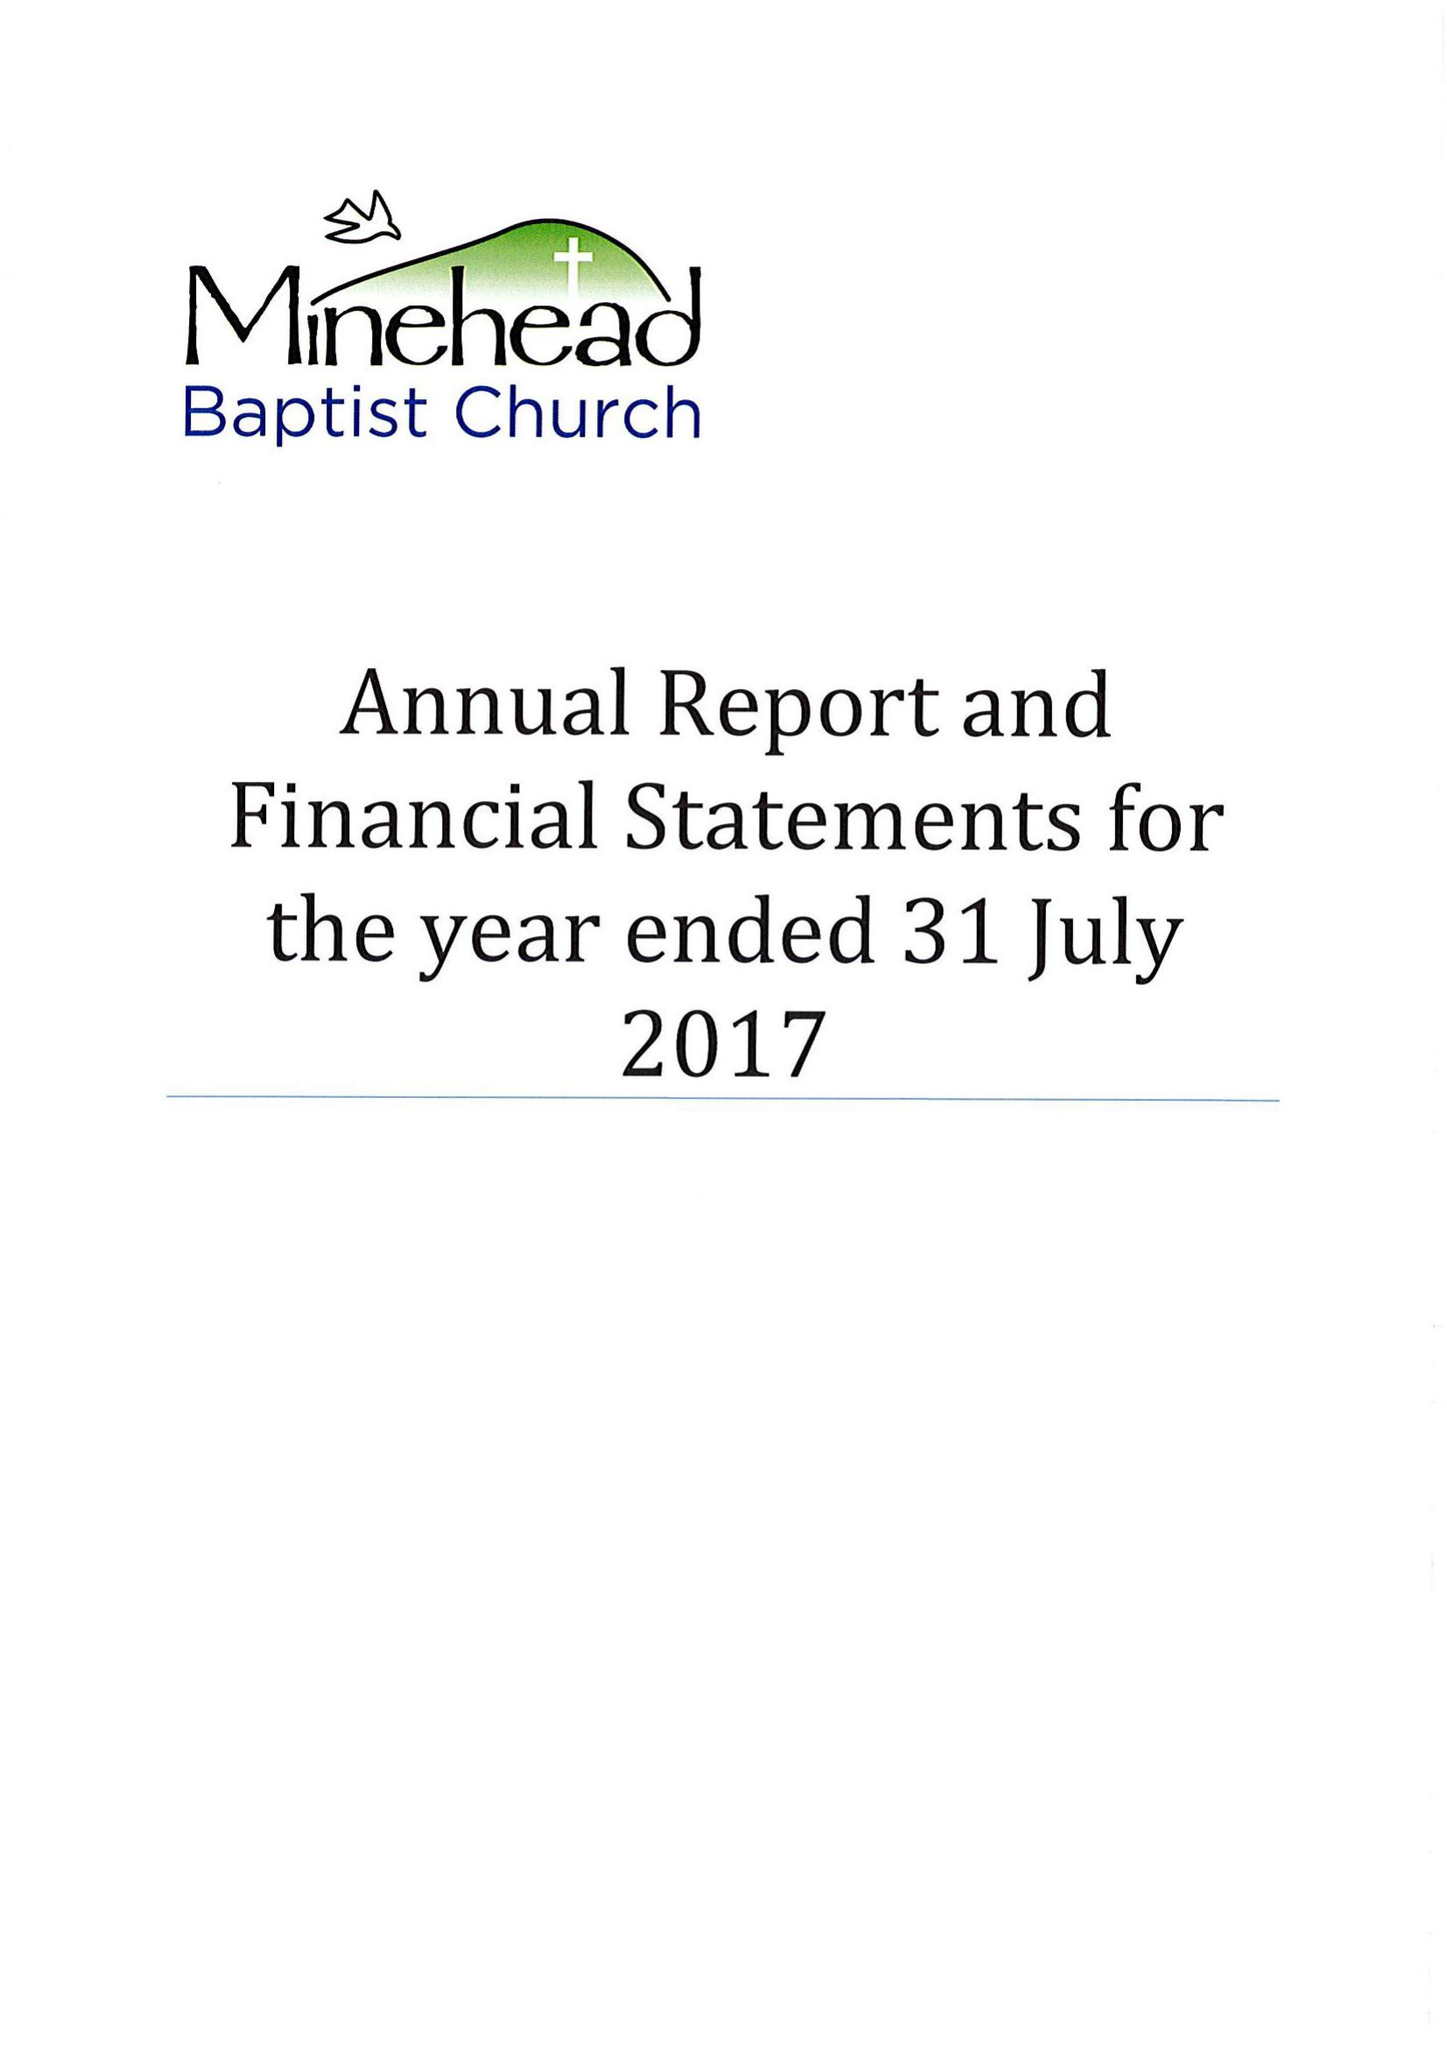What is the value for the spending_annually_in_british_pounds?
Answer the question using a single word or phrase. 257489.00 